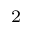Convert formula to latex. <formula><loc_0><loc_0><loc_500><loc_500>^ { 2 }</formula> 